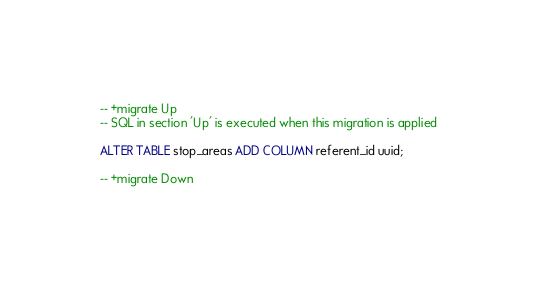<code> <loc_0><loc_0><loc_500><loc_500><_SQL_>-- +migrate Up
-- SQL in section 'Up' is executed when this migration is applied

ALTER TABLE stop_areas ADD COLUMN referent_id uuid;

-- +migrate Down</code> 